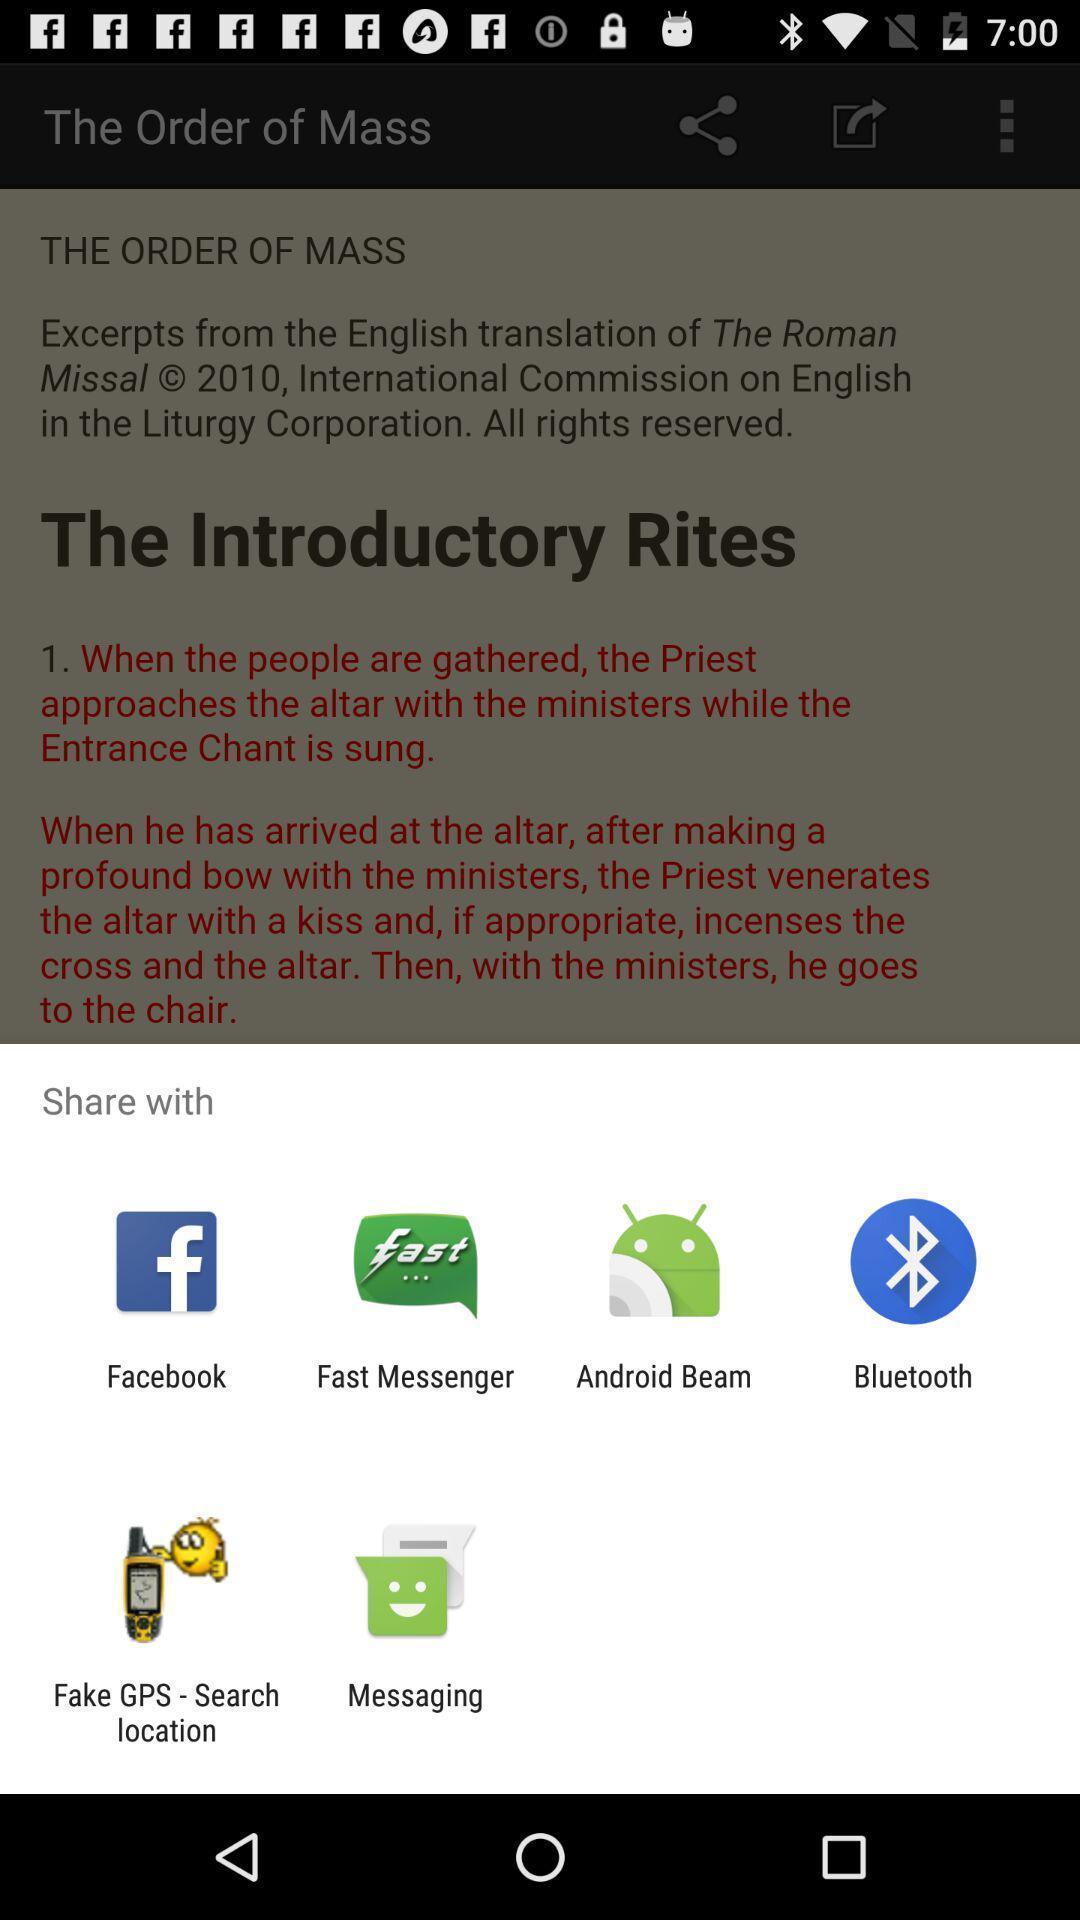Please provide a description for this image. Share page to select through which app to complete action. 